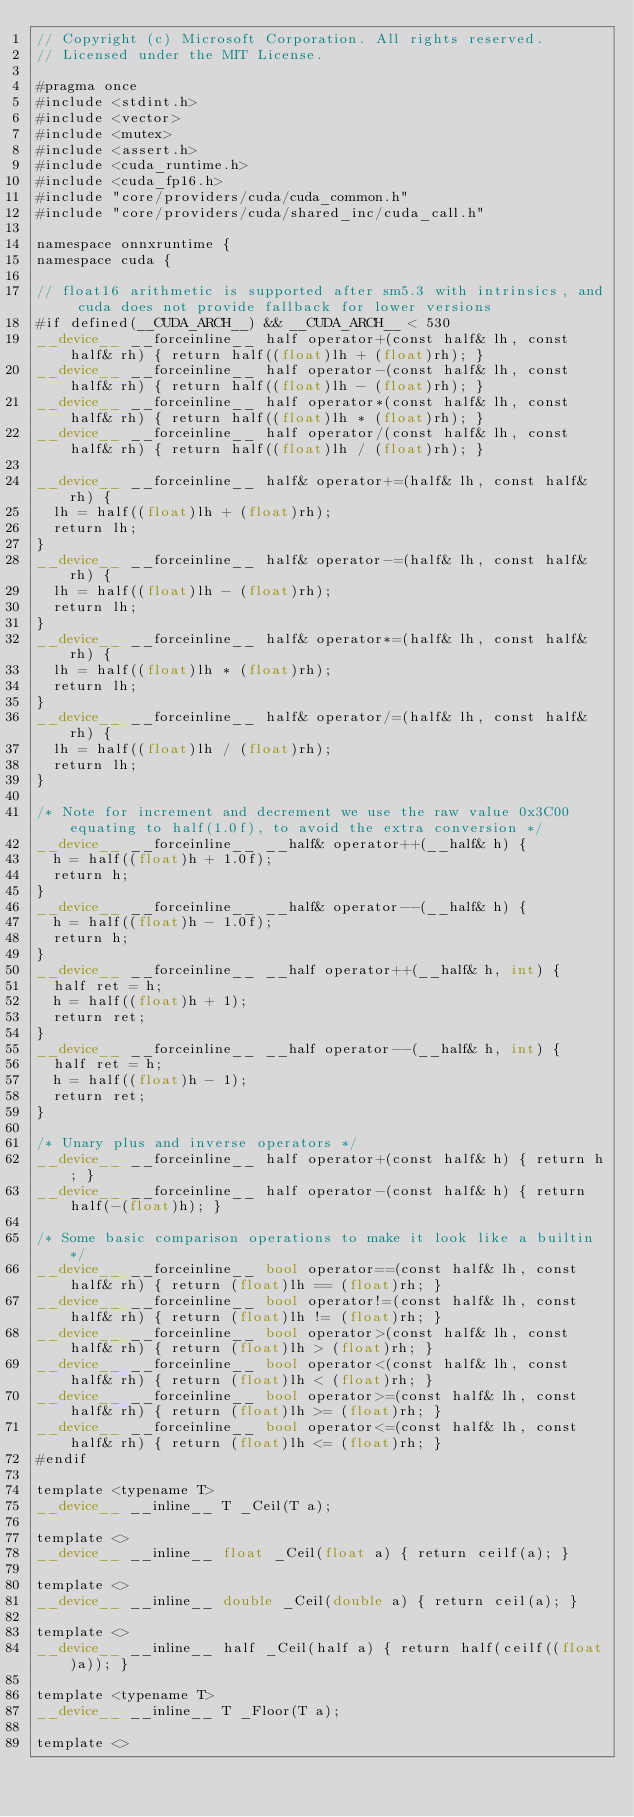<code> <loc_0><loc_0><loc_500><loc_500><_Cuda_>// Copyright (c) Microsoft Corporation. All rights reserved.
// Licensed under the MIT License.

#pragma once
#include <stdint.h>
#include <vector>
#include <mutex>
#include <assert.h>
#include <cuda_runtime.h>
#include <cuda_fp16.h>
#include "core/providers/cuda/cuda_common.h"
#include "core/providers/cuda/shared_inc/cuda_call.h"

namespace onnxruntime {
namespace cuda {

// float16 arithmetic is supported after sm5.3 with intrinsics, and cuda does not provide fallback for lower versions
#if defined(__CUDA_ARCH__) && __CUDA_ARCH__ < 530
__device__ __forceinline__ half operator+(const half& lh, const half& rh) { return half((float)lh + (float)rh); }
__device__ __forceinline__ half operator-(const half& lh, const half& rh) { return half((float)lh - (float)rh); }
__device__ __forceinline__ half operator*(const half& lh, const half& rh) { return half((float)lh * (float)rh); }
__device__ __forceinline__ half operator/(const half& lh, const half& rh) { return half((float)lh / (float)rh); }

__device__ __forceinline__ half& operator+=(half& lh, const half& rh) {
  lh = half((float)lh + (float)rh);
  return lh;
}
__device__ __forceinline__ half& operator-=(half& lh, const half& rh) {
  lh = half((float)lh - (float)rh);
  return lh;
}
__device__ __forceinline__ half& operator*=(half& lh, const half& rh) {
  lh = half((float)lh * (float)rh);
  return lh;
}
__device__ __forceinline__ half& operator/=(half& lh, const half& rh) {
  lh = half((float)lh / (float)rh);
  return lh;
}

/* Note for increment and decrement we use the raw value 0x3C00 equating to half(1.0f), to avoid the extra conversion */
__device__ __forceinline__ __half& operator++(__half& h) {
  h = half((float)h + 1.0f);
  return h;
}
__device__ __forceinline__ __half& operator--(__half& h) {
  h = half((float)h - 1.0f);
  return h;
}
__device__ __forceinline__ __half operator++(__half& h, int) {
  half ret = h;
  h = half((float)h + 1);
  return ret;
}
__device__ __forceinline__ __half operator--(__half& h, int) {
  half ret = h;
  h = half((float)h - 1);
  return ret;
}

/* Unary plus and inverse operators */
__device__ __forceinline__ half operator+(const half& h) { return h; }
__device__ __forceinline__ half operator-(const half& h) { return half(-(float)h); }

/* Some basic comparison operations to make it look like a builtin */
__device__ __forceinline__ bool operator==(const half& lh, const half& rh) { return (float)lh == (float)rh; }
__device__ __forceinline__ bool operator!=(const half& lh, const half& rh) { return (float)lh != (float)rh; }
__device__ __forceinline__ bool operator>(const half& lh, const half& rh) { return (float)lh > (float)rh; }
__device__ __forceinline__ bool operator<(const half& lh, const half& rh) { return (float)lh < (float)rh; }
__device__ __forceinline__ bool operator>=(const half& lh, const half& rh) { return (float)lh >= (float)rh; }
__device__ __forceinline__ bool operator<=(const half& lh, const half& rh) { return (float)lh <= (float)rh; }
#endif

template <typename T>
__device__ __inline__ T _Ceil(T a);

template <>
__device__ __inline__ float _Ceil(float a) { return ceilf(a); }

template <>
__device__ __inline__ double _Ceil(double a) { return ceil(a); }

template <>
__device__ __inline__ half _Ceil(half a) { return half(ceilf((float)a)); }

template <typename T>
__device__ __inline__ T _Floor(T a);

template <></code> 